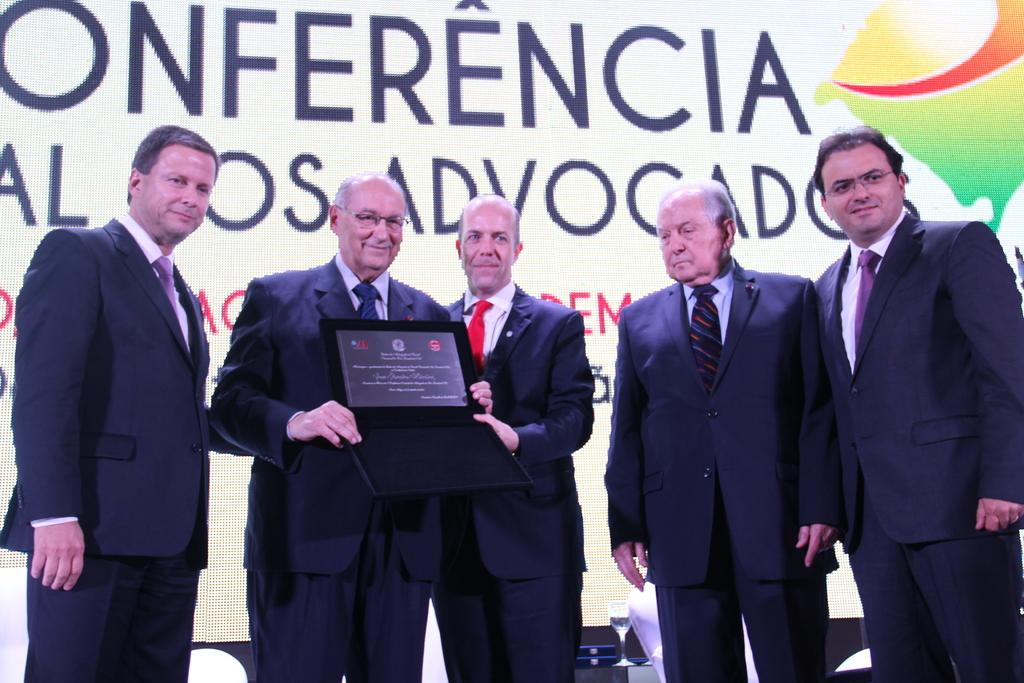What is happening in the middle of the image? There are people standing in the middle of the image. What is the facial expression of the people? The people are smiling. What are two of the people holding? Two of the people are holding a frame. What can be seen in the background of the image? There is a banner visible in the background. Can you tell me how many giraffes are in the image? There are no giraffes present in the image. Is there a basketball game happening in the background? There is no basketball game visible in the image. 